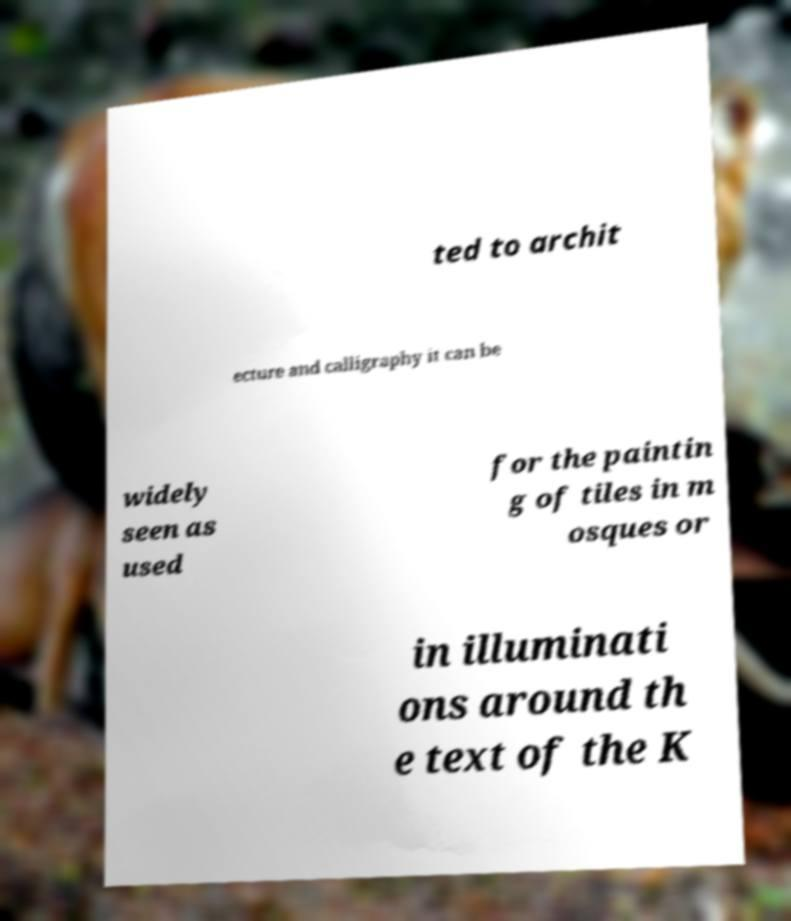Could you assist in decoding the text presented in this image and type it out clearly? ted to archit ecture and calligraphy it can be widely seen as used for the paintin g of tiles in m osques or in illuminati ons around th e text of the K 